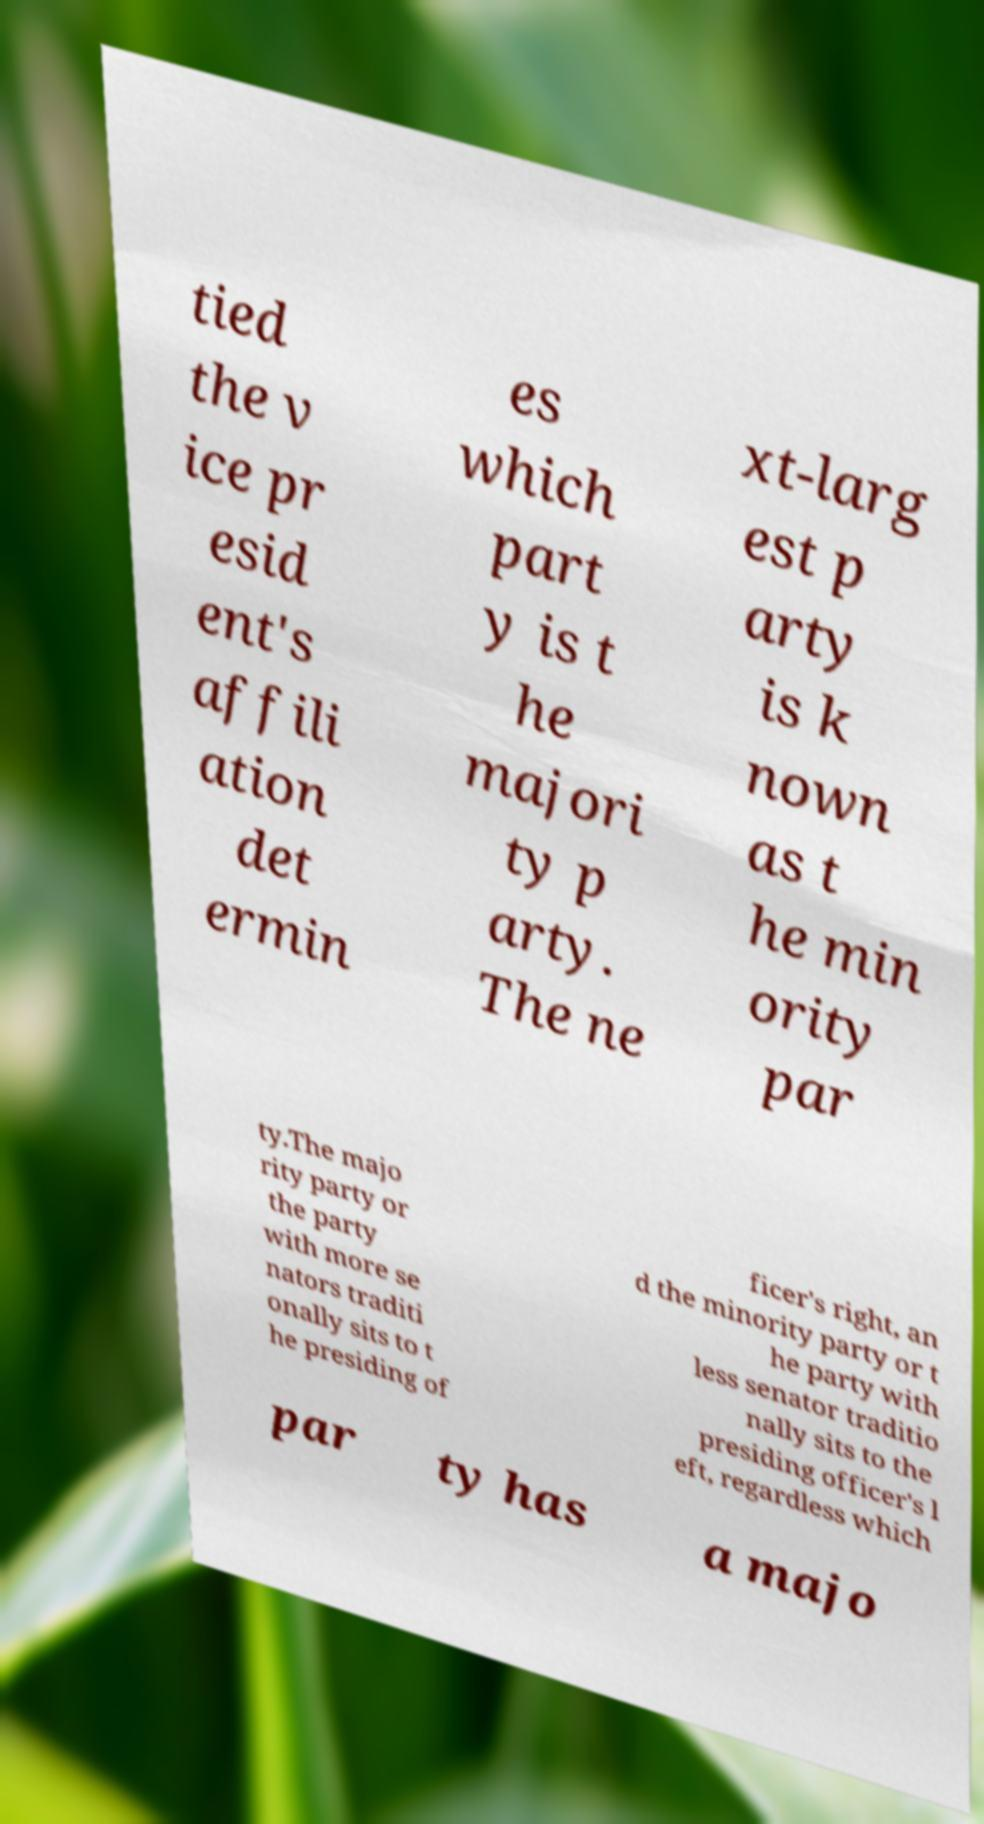Can you accurately transcribe the text from the provided image for me? tied the v ice pr esid ent's affili ation det ermin es which part y is t he majori ty p arty. The ne xt-larg est p arty is k nown as t he min ority par ty.The majo rity party or the party with more se nators traditi onally sits to t he presiding of ficer's right, an d the minority party or t he party with less senator traditio nally sits to the presiding officer's l eft, regardless which par ty has a majo 